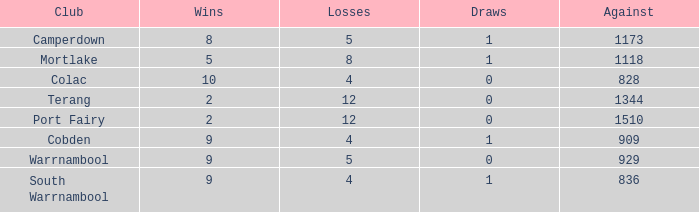What is the sum of losses for Against values over 1510? None. 